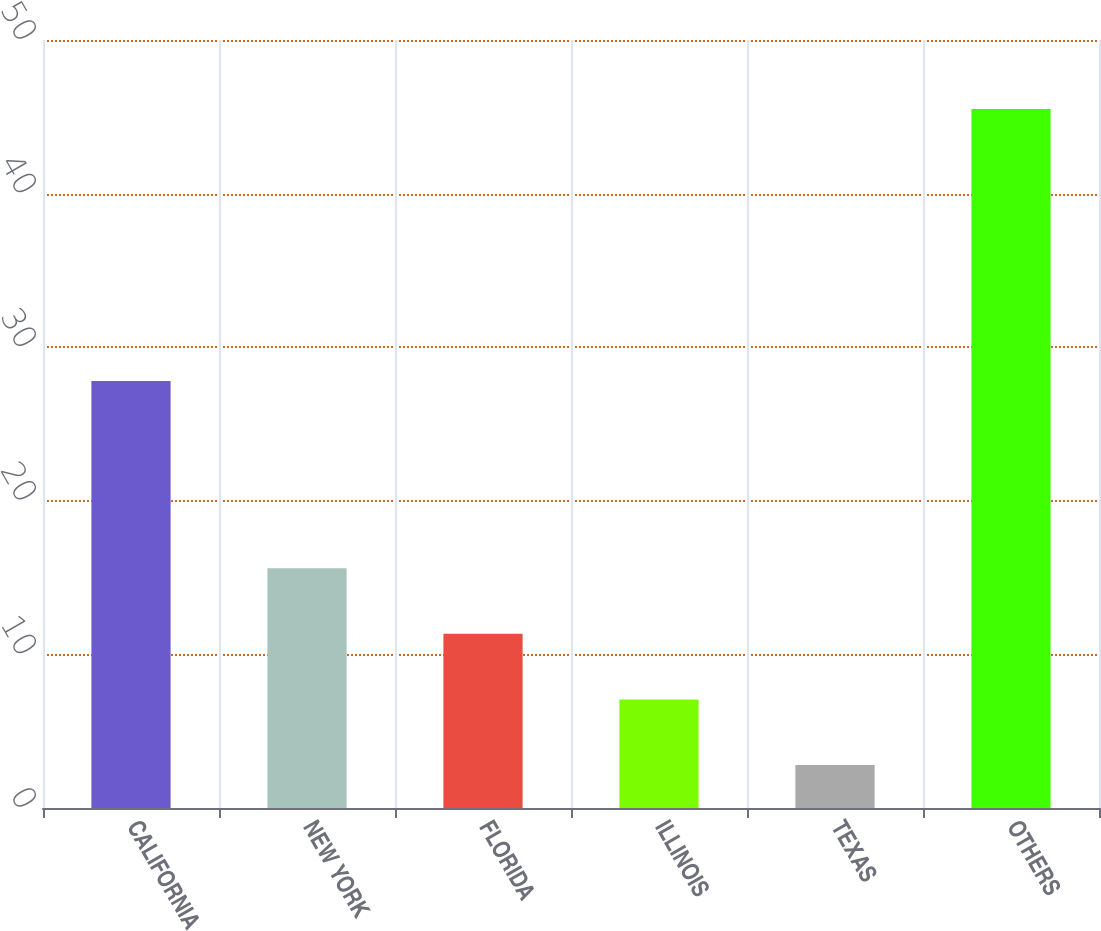<chart> <loc_0><loc_0><loc_500><loc_500><bar_chart><fcel>CALIFORNIA<fcel>NEW YORK<fcel>FLORIDA<fcel>ILLINOIS<fcel>TEXAS<fcel>OTHERS<nl><fcel>27.8<fcel>15.61<fcel>11.34<fcel>7.07<fcel>2.8<fcel>45.5<nl></chart> 